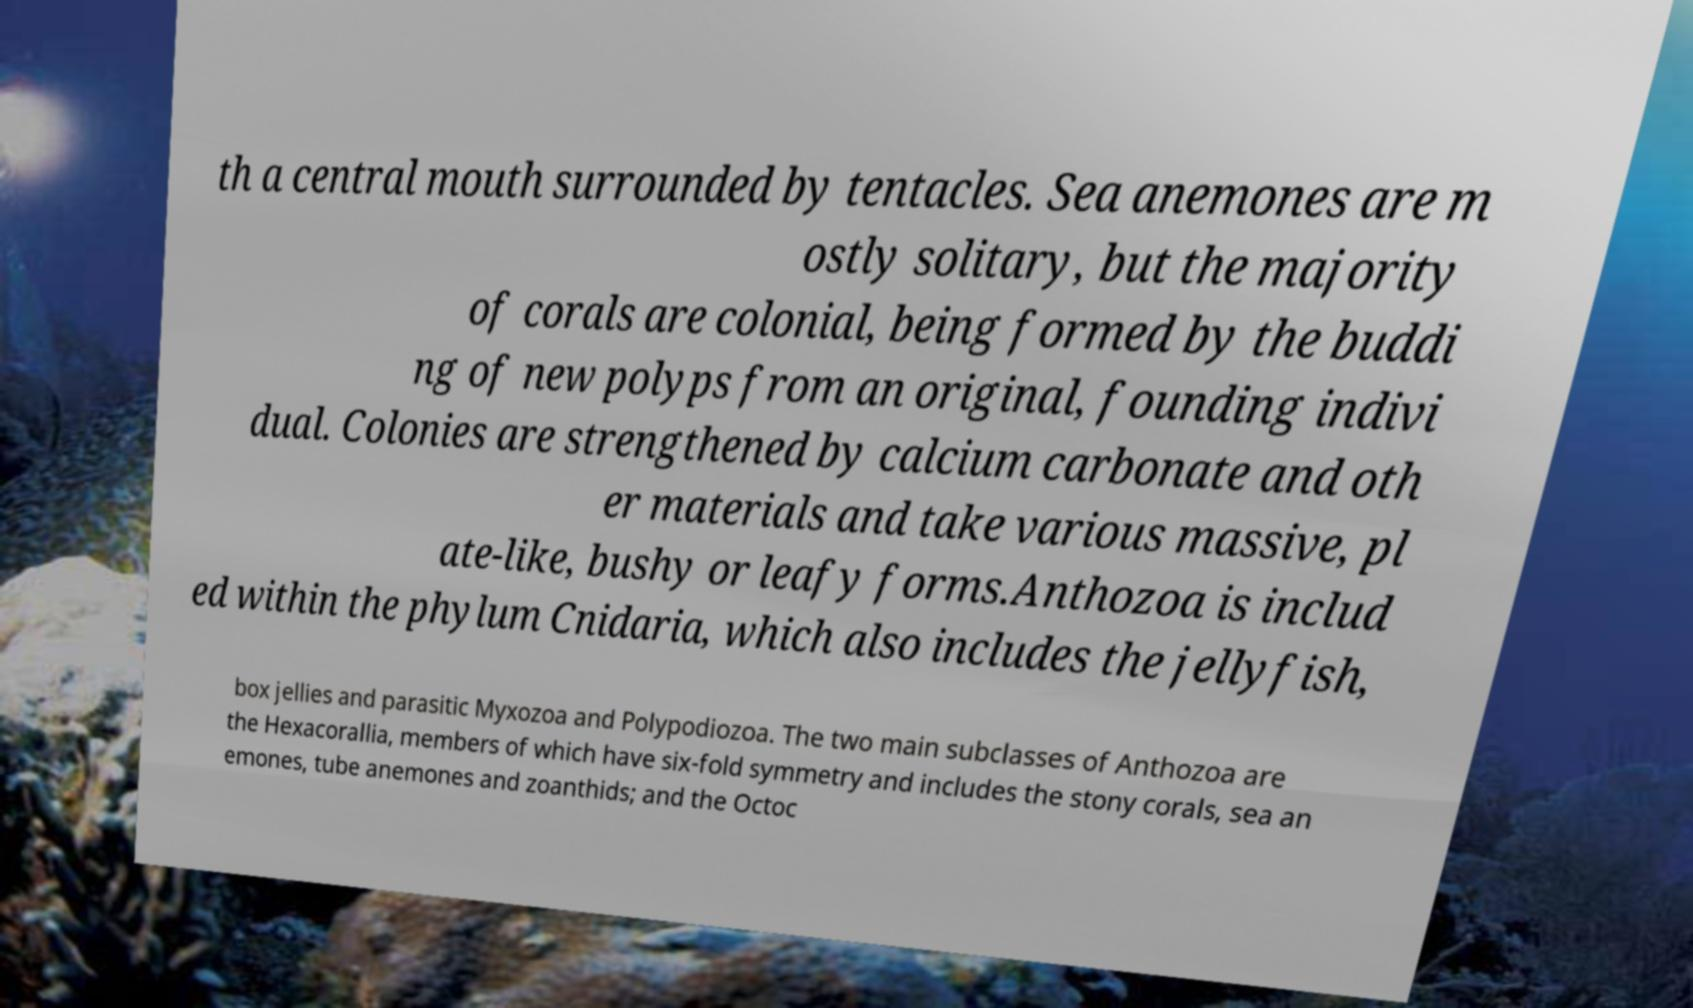Can you read and provide the text displayed in the image?This photo seems to have some interesting text. Can you extract and type it out for me? th a central mouth surrounded by tentacles. Sea anemones are m ostly solitary, but the majority of corals are colonial, being formed by the buddi ng of new polyps from an original, founding indivi dual. Colonies are strengthened by calcium carbonate and oth er materials and take various massive, pl ate-like, bushy or leafy forms.Anthozoa is includ ed within the phylum Cnidaria, which also includes the jellyfish, box jellies and parasitic Myxozoa and Polypodiozoa. The two main subclasses of Anthozoa are the Hexacorallia, members of which have six-fold symmetry and includes the stony corals, sea an emones, tube anemones and zoanthids; and the Octoc 